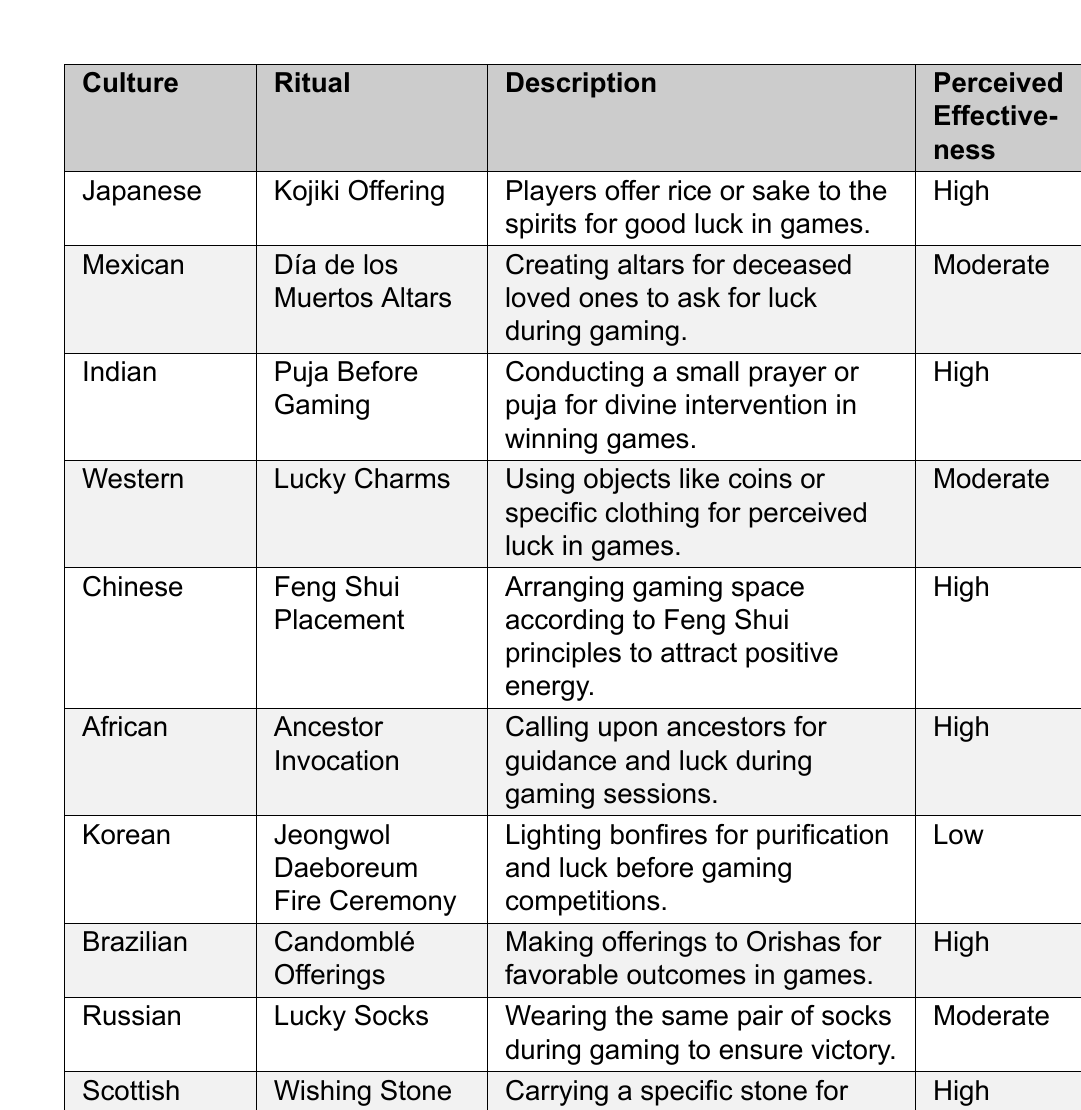What is the ritual associated with African culture? The table identifies the ritual associated with African culture as "Ancestor Invocation."
Answer: Ancestor Invocation Which culture has a ritual with high perceived effectiveness involving Feng Shui? According to the table, the Chinese culture has a ritual called "Feng Shui Placement" with high perceived effectiveness.
Answer: Chinese culture How many rituals are listed with a perceived effectiveness of "Moderate"? There are three rituals listed as having moderate perceived effectiveness. They are from Mexican, Western, and Russian cultures respectively.
Answer: 3 Is the "Jeongwol Daeboreum Fire Ceremony" rated as high for perceived effectiveness? The table clearly states that the perceived effectiveness of the "Jeongwol Daeboreum Fire Ceremony" from Korean culture is rated as low.
Answer: No What common factor do the Japanese and Indian rituals share regarding their perceived effectiveness? Both the Kojiki Offering (Japanese) and Puja Before Gaming (Indian) rituals are rated as having high perceived effectiveness.
Answer: High perceived effectiveness Which culture's gaming ritual is focused on lighting bonfires, and what is its perceived effectiveness? The Korean culture's gaming ritual is the "Jeongwol Daeboreum Fire Ceremony," which has a low perceived effectiveness.
Answer: Low perceived effectiveness How many cultures have high perceived effectiveness rituals for gaming? There are five cultures listed in the table that have high perceived effectiveness rituals: Japanese, Indian, Chinese, African, Brazilian, and Scottish.
Answer: 6 Which ritual involves making offerings to Orishas, and what is its perceived effectiveness? The Brazilian ritual named "Candomblé Offerings" involves making offerings to Orishas and is rated as having high perceived effectiveness.
Answer: High perceived effectiveness If you combine the perceived effectiveness of all rituals, what is the total count of those rated high? Count the entries rated as high: Japanese, Indian, Chinese, African, Brazilian, and Scottish. This totals six.
Answer: 6 Do Western rituals include offerings to ancestors? The table shows that Western rituals involve using lucky charms, and there are no offerings to ancestors listed under Western culture.
Answer: No 